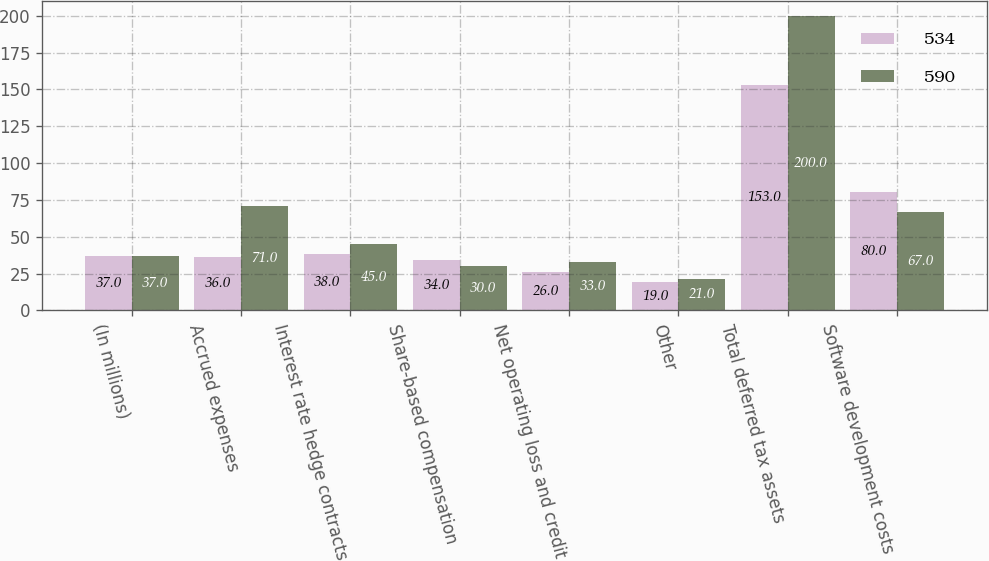Convert chart. <chart><loc_0><loc_0><loc_500><loc_500><stacked_bar_chart><ecel><fcel>(In millions)<fcel>Accrued expenses<fcel>Interest rate hedge contracts<fcel>Share-based compensation<fcel>Net operating loss and credit<fcel>Other<fcel>Total deferred tax assets<fcel>Software development costs<nl><fcel>534<fcel>37<fcel>36<fcel>38<fcel>34<fcel>26<fcel>19<fcel>153<fcel>80<nl><fcel>590<fcel>37<fcel>71<fcel>45<fcel>30<fcel>33<fcel>21<fcel>200<fcel>67<nl></chart> 